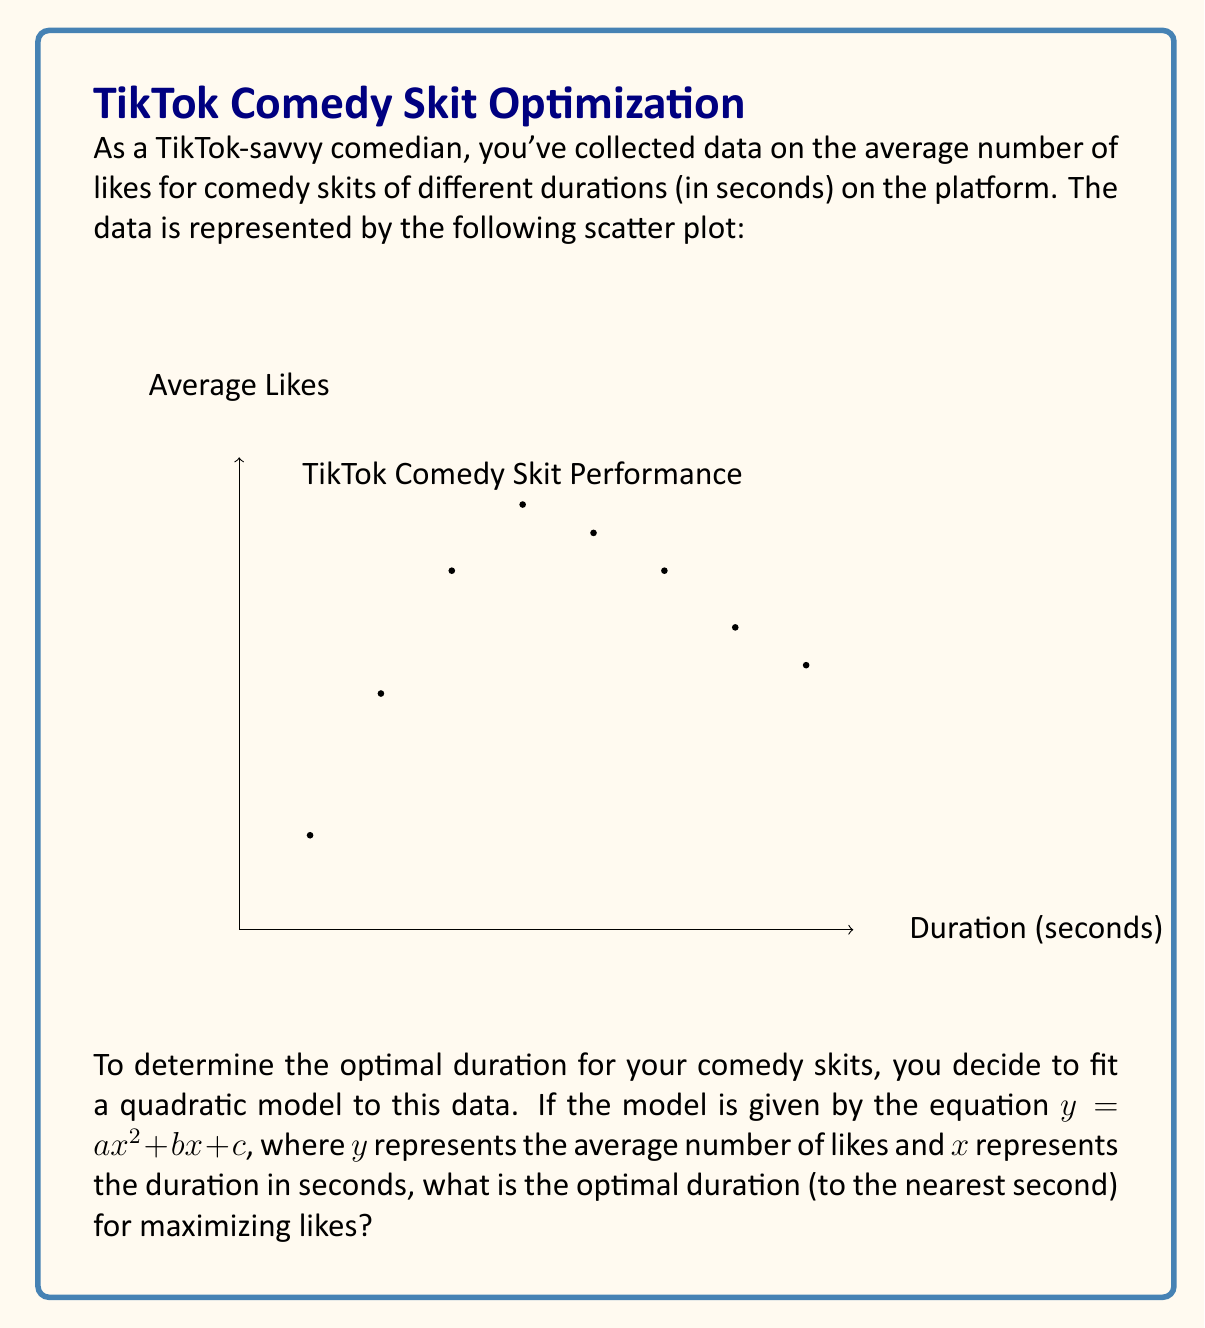Show me your answer to this math problem. Let's approach this step-by-step:

1) We're given a quadratic model $y = ax^2 + bx + c$. To find the optimal duration, we need to find the vertex of this parabola.

2) For a quadratic function, the x-coordinate of the vertex is given by $x = -\frac{b}{2a}$.

3) While we don't have the exact values of $a$, $b$, and $c$, we can estimate them from the graph:

   - The parabola opens downward, so $a < 0$.
   - The vertex appears to be around 60 seconds.
   - The y-intercept (c) seems to be close to 0.

4) We don't need to calculate the exact values of $a$, $b$, and $c$. The important observation is that the vertex of the parabola represents the maximum point.

5) From the graph, we can see that the highest point of the curve is around 60 seconds.

6) This aligns with our understanding of TikTok's format, where videos around 1 minute tend to perform well.

7) To be more precise, we can see that the data point at 60 seconds has the highest y-value (average likes).

Therefore, based on this quadratic model and the given data, the optimal duration for maximizing likes is approximately 60 seconds.
Answer: 60 seconds 